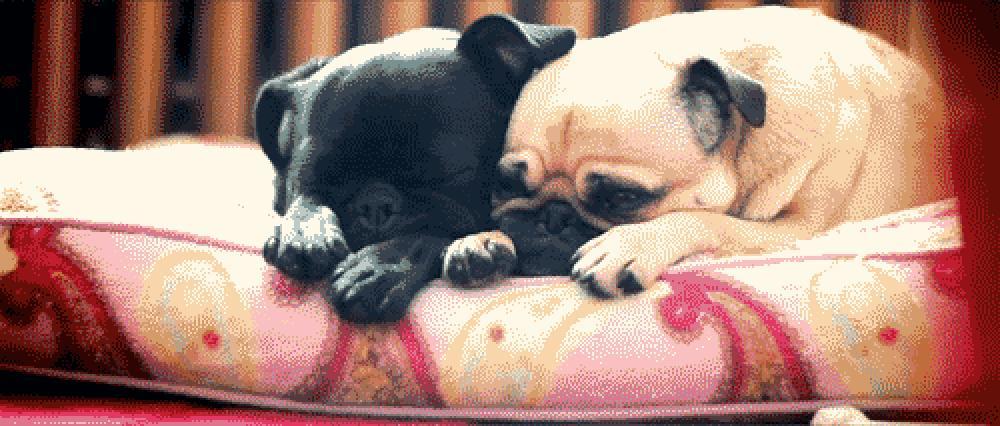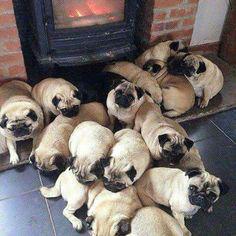The first image is the image on the left, the second image is the image on the right. Examine the images to the left and right. Is the description "All of the dogs are the same color and none of them are tied on a leash." accurate? Answer yes or no. No. The first image is the image on the left, the second image is the image on the right. Given the left and right images, does the statement "There are more pug dogs in the right image than in the left." hold true? Answer yes or no. Yes. 